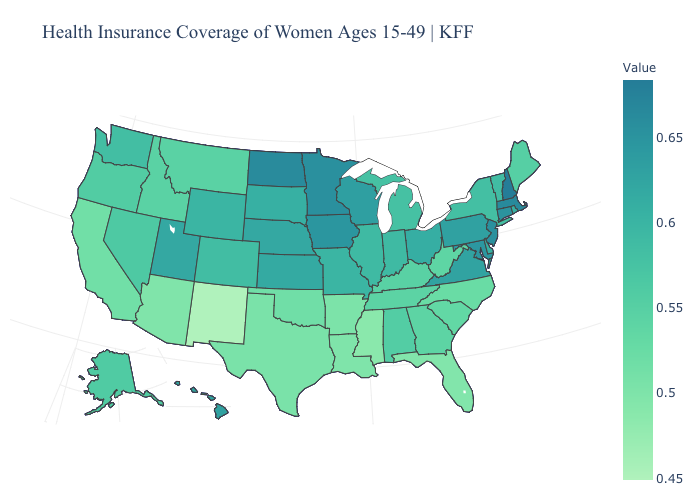Does West Virginia have a lower value than New Jersey?
Be succinct. Yes. Does Mississippi have the highest value in the South?
Give a very brief answer. No. Which states have the lowest value in the USA?
Be succinct. New Mexico. Does New Mexico have the lowest value in the USA?
Give a very brief answer. Yes. Among the states that border North Dakota , which have the lowest value?
Give a very brief answer. Montana. Among the states that border Maryland , does West Virginia have the highest value?
Concise answer only. No. Does Ohio have a higher value than Idaho?
Write a very short answer. Yes. Does Idaho have the lowest value in the West?
Quick response, please. No. Does the map have missing data?
Answer briefly. No. 